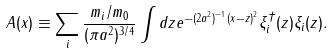Convert formula to latex. <formula><loc_0><loc_0><loc_500><loc_500>A ( { x } ) \equiv \sum _ { i } \frac { m _ { i } / m _ { 0 } } { ( \pi a ^ { 2 } ) ^ { 3 / 4 } } \int d { z } e ^ { - ( 2 a ^ { 2 } ) ^ { - 1 } ( { x } - { z } ) ^ { 2 } } \xi _ { i } ^ { \dagger } ( { z } ) \xi _ { i } ( { z } ) .</formula> 